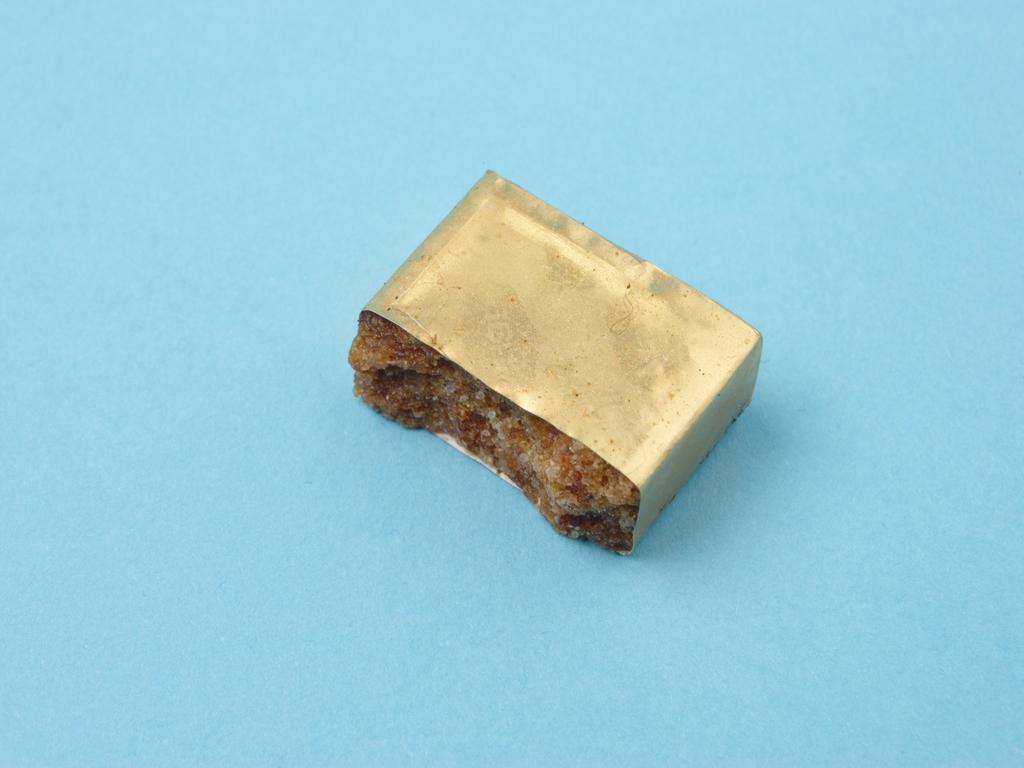In one or two sentences, can you explain what this image depicts? In this picture I can see a gold and brown color thing on the blue color surface. 